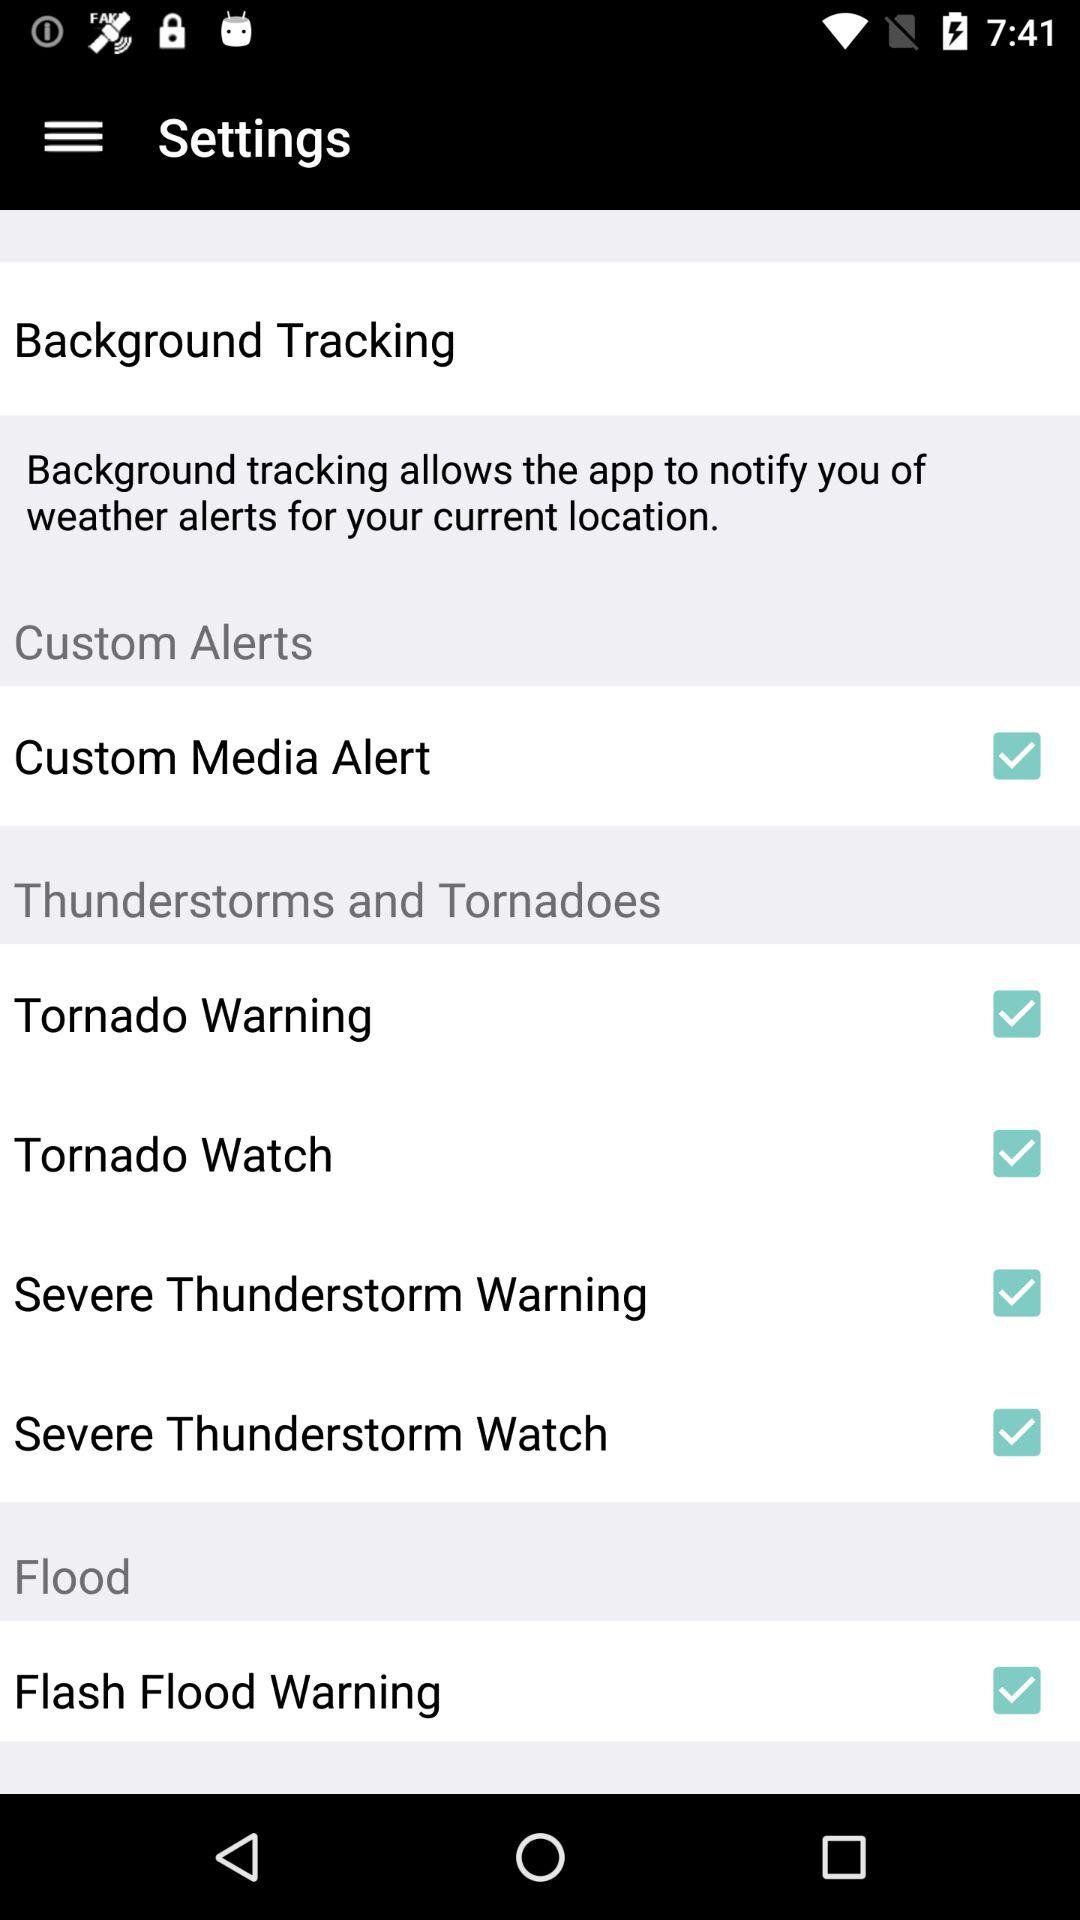What is the status of "Tornado Warning" in "Thunderstorms and Tornadoes"? The status is "on". 